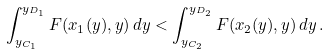<formula> <loc_0><loc_0><loc_500><loc_500>\int _ { y _ { C _ { 1 } } } ^ { y _ { D _ { 1 } } } F ( x _ { 1 } ( y ) , y ) \, d y < \int _ { y _ { C _ { 2 } } } ^ { y _ { D _ { 2 } } } F ( x _ { 2 } ( y ) , y ) \, d y \, .</formula> 